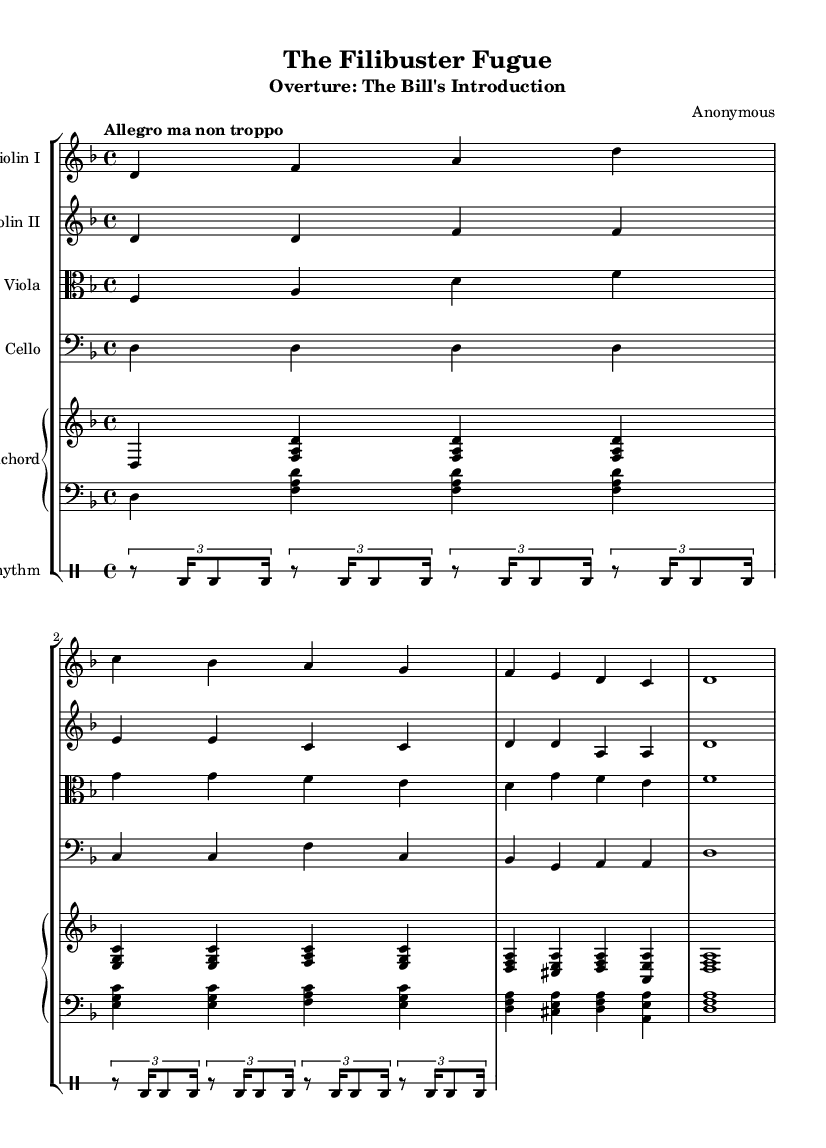What is the key signature of this music? The key signature is D minor, which has one flat (B flat).
Answer: D minor What is the time signature of this music? The time signature is 4/4, indicating four beats per measure.
Answer: 4/4 What is the tempo marking given in the score? The tempo marking is "Allegro ma non troppo", suggesting a lively pace, but not too fast.
Answer: Allegro ma non troppo How many instruments are featured in this piece? There are five distinct staff groups representing different instruments: two violins, a viola, a cello, and a harpsichord.
Answer: Five Which instrument plays the lowest pitch? The cello section plays the lowest pitch range, typically below the other string instruments in this ensemble.
Answer: Cello What form of musical structure is primarily used in this piece? The piece employs an overture format often used in Baroque orchestral suites, which serves as an introduction.
Answer: Overture What unique element characterizes the rhythmic section of this piece? The rhythmic section features a repeated drum pattern indicative of dance rhythms found in Baroque suites.
Answer: Repeated drum pattern 